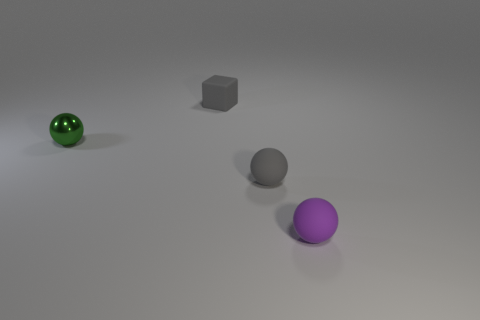Is there any other thing that is the same material as the green thing?
Provide a succinct answer. No. What number of other objects are the same material as the small green ball?
Ensure brevity in your answer.  0. Are there any other things that are the same shape as the tiny metallic thing?
Provide a succinct answer. Yes. What is the color of the matte thing behind the tiny ball that is behind the tiny rubber ball behind the small purple ball?
Give a very brief answer. Gray. The thing that is both on the left side of the gray rubber sphere and to the right of the green object has what shape?
Make the answer very short. Cube. Is there any other thing that is the same size as the purple object?
Give a very brief answer. Yes. What color is the small rubber ball left of the small rubber ball in front of the small gray ball?
Keep it short and to the point. Gray. There is a gray thing that is right of the rubber thing that is behind the small gray object that is in front of the tiny green shiny thing; what shape is it?
Your response must be concise. Sphere. There is a sphere that is to the left of the purple rubber thing and to the right of the tiny green shiny thing; what is its size?
Keep it short and to the point. Small. How many small matte spheres have the same color as the small rubber cube?
Offer a terse response. 1. 